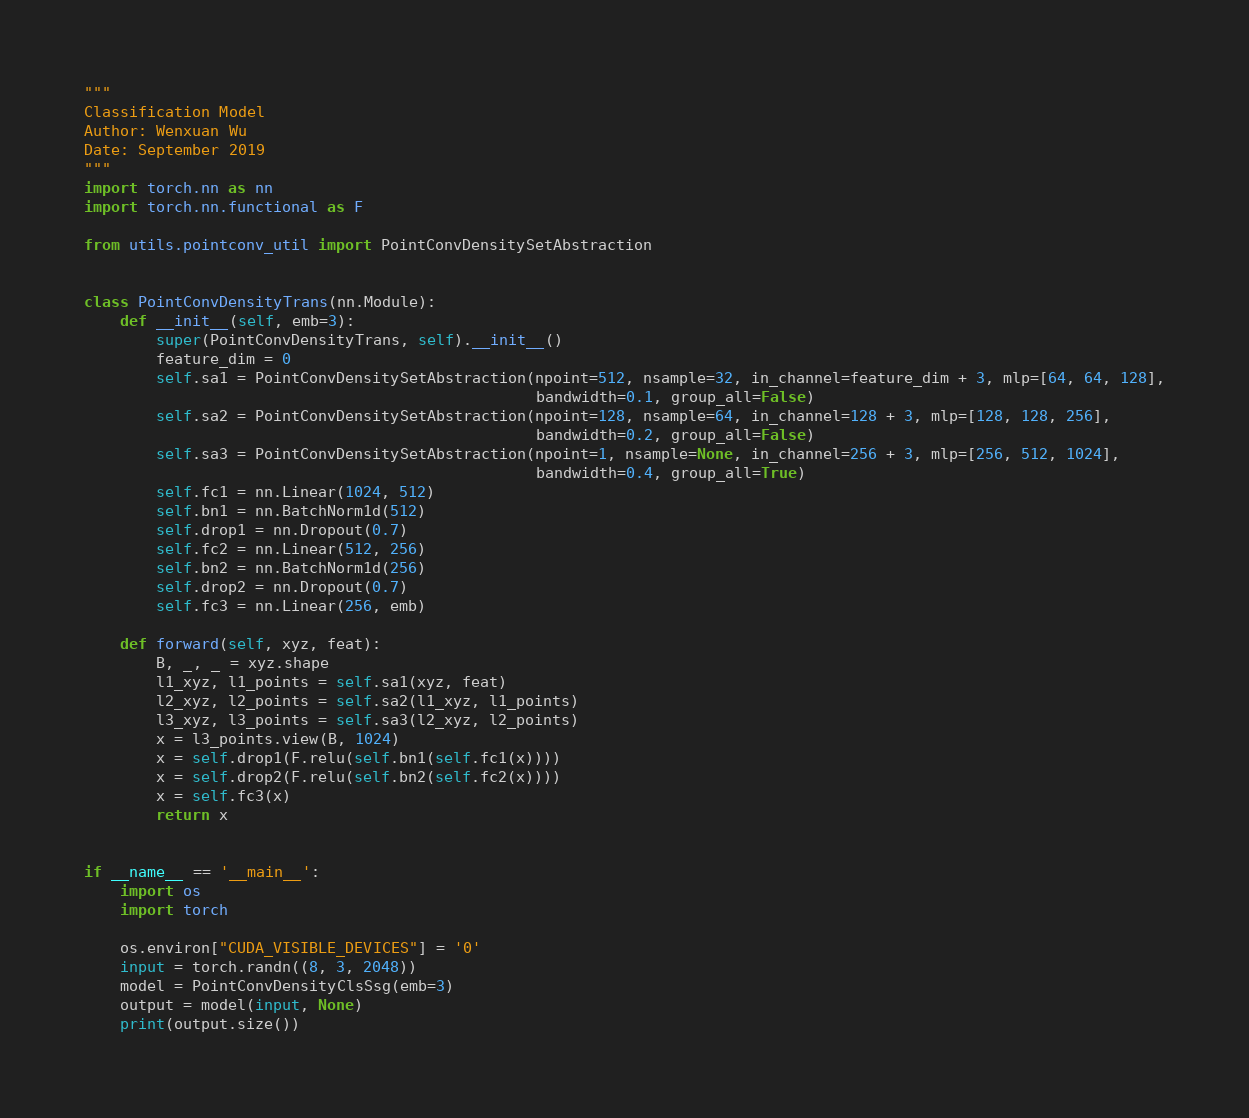<code> <loc_0><loc_0><loc_500><loc_500><_Python_>"""
Classification Model
Author: Wenxuan Wu
Date: September 2019
"""
import torch.nn as nn
import torch.nn.functional as F

from utils.pointconv_util import PointConvDensitySetAbstraction


class PointConvDensityTrans(nn.Module):
    def __init__(self, emb=3):
        super(PointConvDensityTrans, self).__init__()
        feature_dim = 0
        self.sa1 = PointConvDensitySetAbstraction(npoint=512, nsample=32, in_channel=feature_dim + 3, mlp=[64, 64, 128],
                                                  bandwidth=0.1, group_all=False)
        self.sa2 = PointConvDensitySetAbstraction(npoint=128, nsample=64, in_channel=128 + 3, mlp=[128, 128, 256],
                                                  bandwidth=0.2, group_all=False)
        self.sa3 = PointConvDensitySetAbstraction(npoint=1, nsample=None, in_channel=256 + 3, mlp=[256, 512, 1024],
                                                  bandwidth=0.4, group_all=True)
        self.fc1 = nn.Linear(1024, 512)
        self.bn1 = nn.BatchNorm1d(512)
        self.drop1 = nn.Dropout(0.7)
        self.fc2 = nn.Linear(512, 256)
        self.bn2 = nn.BatchNorm1d(256)
        self.drop2 = nn.Dropout(0.7)
        self.fc3 = nn.Linear(256, emb)

    def forward(self, xyz, feat):
        B, _, _ = xyz.shape
        l1_xyz, l1_points = self.sa1(xyz, feat)
        l2_xyz, l2_points = self.sa2(l1_xyz, l1_points)
        l3_xyz, l3_points = self.sa3(l2_xyz, l2_points)
        x = l3_points.view(B, 1024)
        x = self.drop1(F.relu(self.bn1(self.fc1(x))))
        x = self.drop2(F.relu(self.bn2(self.fc2(x))))
        x = self.fc3(x)
        return x


if __name__ == '__main__':
    import os
    import torch

    os.environ["CUDA_VISIBLE_DEVICES"] = '0'
    input = torch.randn((8, 3, 2048))
    model = PointConvDensityClsSsg(emb=3)
    output = model(input, None)
    print(output.size())
</code> 